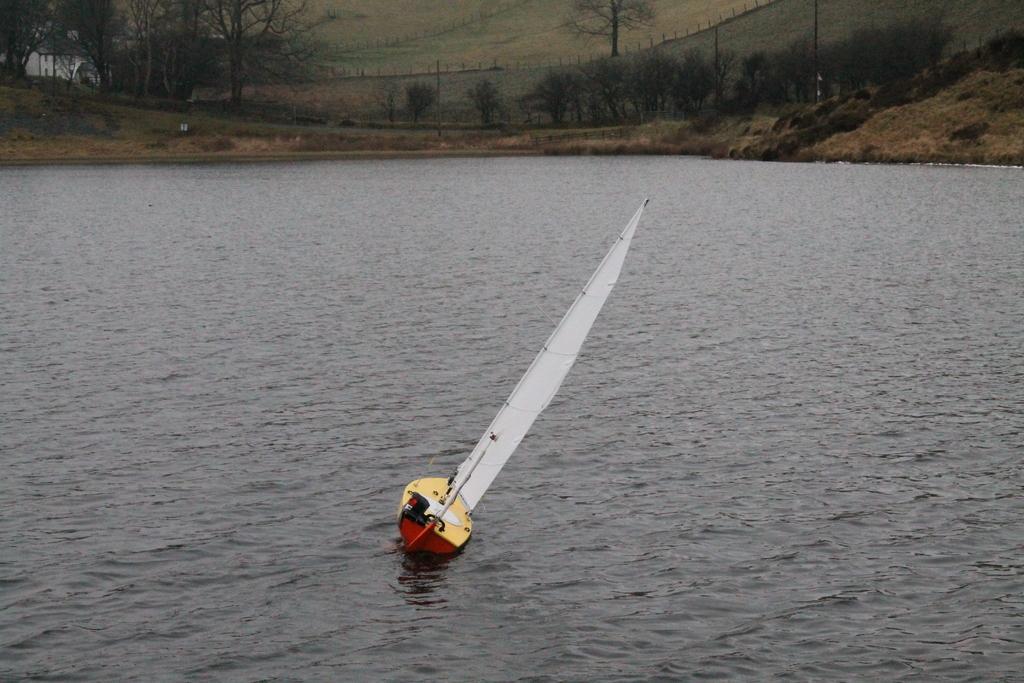Can you describe this image briefly? In this image I can see a boat on the water. There are trees, there is grass, there is a building and there is a wall. 